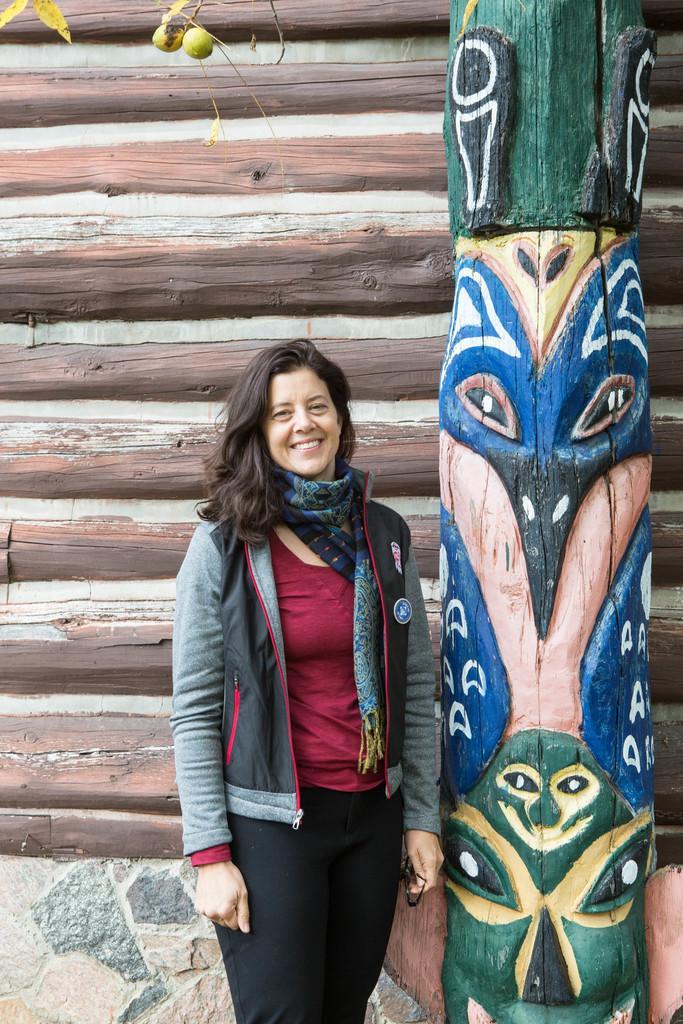In one or two sentences, can you explain what this image depicts? In the middle of the image a woman is standing and smiling. Beside her we can see a painting on a wooden board. Behind her we can see a wall. 